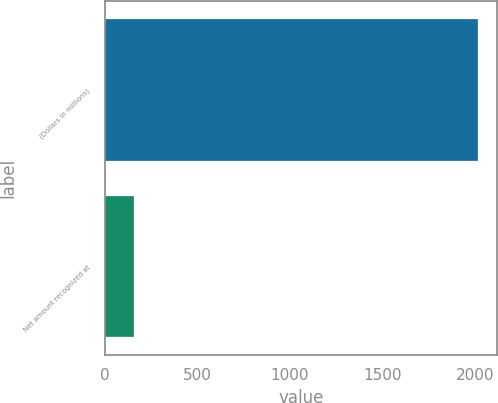Convert chart. <chart><loc_0><loc_0><loc_500><loc_500><bar_chart><fcel>(Dollars in millions)<fcel>Net amount recognized at<nl><fcel>2015<fcel>158<nl></chart> 